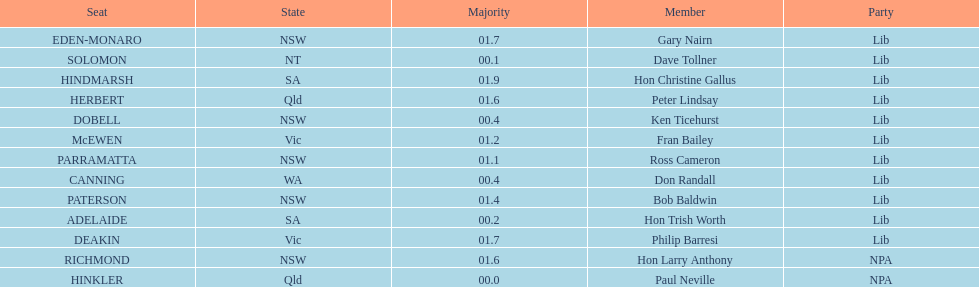Tell me the number of seats from nsw? 5. Give me the full table as a dictionary. {'header': ['Seat', 'State', 'Majority', 'Member', 'Party'], 'rows': [['EDEN-MONARO', 'NSW', '01.7', 'Gary Nairn', 'Lib'], ['SOLOMON', 'NT', '00.1', 'Dave Tollner', 'Lib'], ['HINDMARSH', 'SA', '01.9', 'Hon Christine Gallus', 'Lib'], ['HERBERT', 'Qld', '01.6', 'Peter Lindsay', 'Lib'], ['DOBELL', 'NSW', '00.4', 'Ken Ticehurst', 'Lib'], ['McEWEN', 'Vic', '01.2', 'Fran Bailey', 'Lib'], ['PARRAMATTA', 'NSW', '01.1', 'Ross Cameron', 'Lib'], ['CANNING', 'WA', '00.4', 'Don Randall', 'Lib'], ['PATERSON', 'NSW', '01.4', 'Bob Baldwin', 'Lib'], ['ADELAIDE', 'SA', '00.2', 'Hon Trish Worth', 'Lib'], ['DEAKIN', 'Vic', '01.7', 'Philip Barresi', 'Lib'], ['RICHMOND', 'NSW', '01.6', 'Hon Larry Anthony', 'NPA'], ['HINKLER', 'Qld', '00.0', 'Paul Neville', 'NPA']]} 